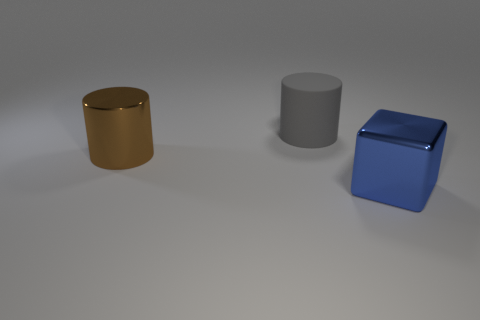Add 3 brown things. How many objects exist? 6 Subtract all blocks. How many objects are left? 2 Subtract all gray cylinders. Subtract all purple balls. How many cylinders are left? 1 Subtract all tiny blue cubes. Subtract all blue metal blocks. How many objects are left? 2 Add 3 gray rubber cylinders. How many gray rubber cylinders are left? 4 Add 1 big blue shiny cylinders. How many big blue shiny cylinders exist? 1 Subtract 1 gray cylinders. How many objects are left? 2 